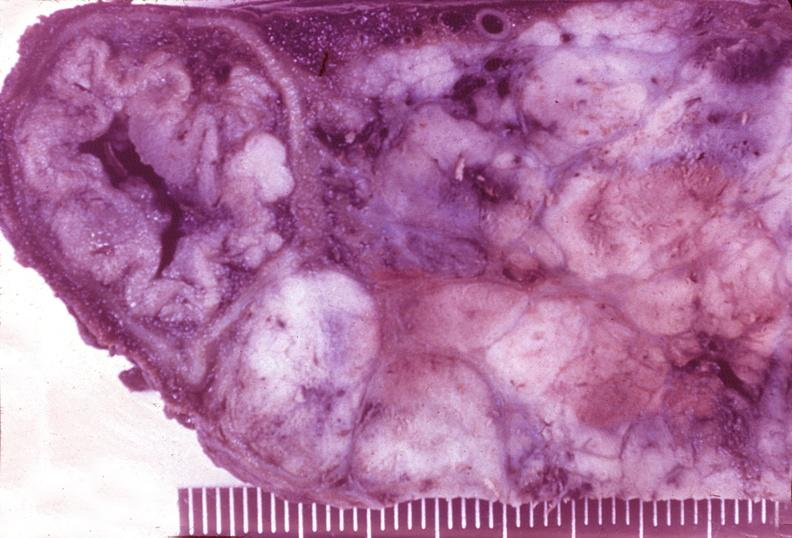s pancreas present?
Answer the question using a single word or phrase. Yes 